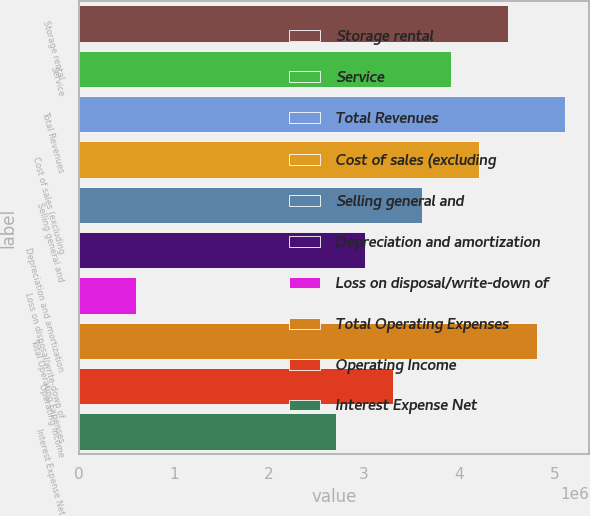Convert chart. <chart><loc_0><loc_0><loc_500><loc_500><bar_chart><fcel>Storage rental<fcel>Service<fcel>Total Revenues<fcel>Cost of sales (excluding<fcel>Selling general and<fcel>Depreciation and amortization<fcel>Loss on disposal/write-down of<fcel>Total Operating Expenses<fcel>Operating Income<fcel>Interest Expense Net<nl><fcel>4.51154e+06<fcel>3.91011e+06<fcel>5.11296e+06<fcel>4.21083e+06<fcel>3.6094e+06<fcel>3.00798e+06<fcel>602275<fcel>4.81225e+06<fcel>3.30869e+06<fcel>2.70726e+06<nl></chart> 